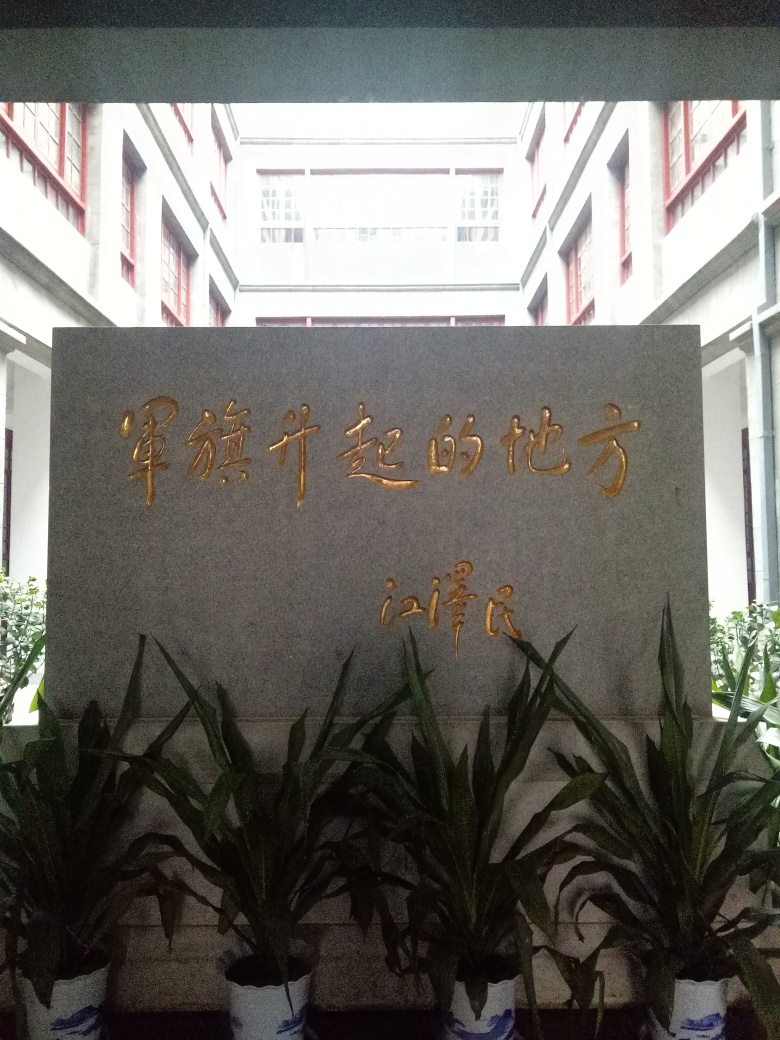What does the architecture in the background suggest about this location? The red windows and the layout of the building suggest an institutional or educational building. The architecture hints at a functional design, likely indicating that this place serves a public or community role. What might be the significance of the color scheme present in the image? The golden text and the red windows against the gray background reflect a color scheme that is often associated with Chinese culture, symbolizing prosperity, happiness, and good fortune. Such a color scheme in a formal setting could connote importance and tradition. 